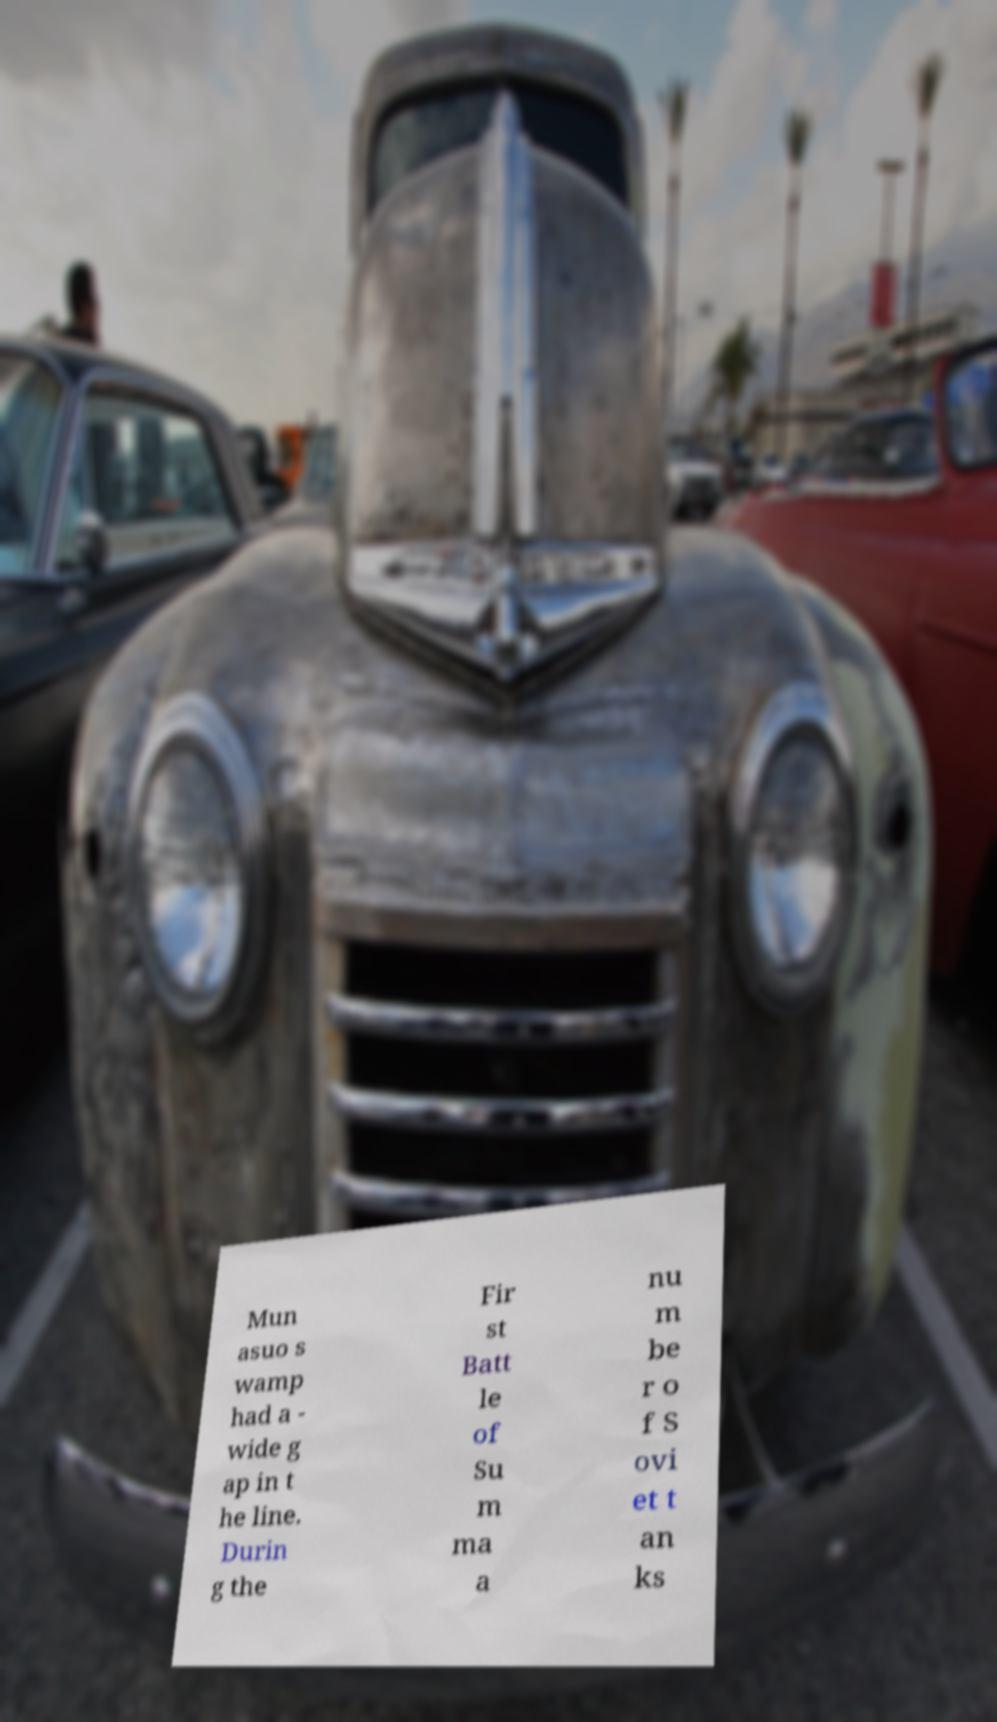For documentation purposes, I need the text within this image transcribed. Could you provide that? Mun asuo s wamp had a - wide g ap in t he line. Durin g the Fir st Batt le of Su m ma a nu m be r o f S ovi et t an ks 